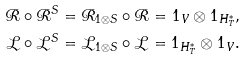<formula> <loc_0><loc_0><loc_500><loc_500>\mathcal { R } \circ \mathcal { R } ^ { S } & = \mathcal { R } _ { 1 \otimes S } \circ \mathcal { R } = 1 _ { V } \otimes 1 _ { H ^ { * } _ { T } } , \\ \mathcal { L } \circ \mathcal { L } ^ { S } & = \mathcal { L } _ { 1 \otimes S } \circ \mathcal { L } = 1 _ { H ^ { * } _ { T } } \otimes 1 _ { V } .</formula> 